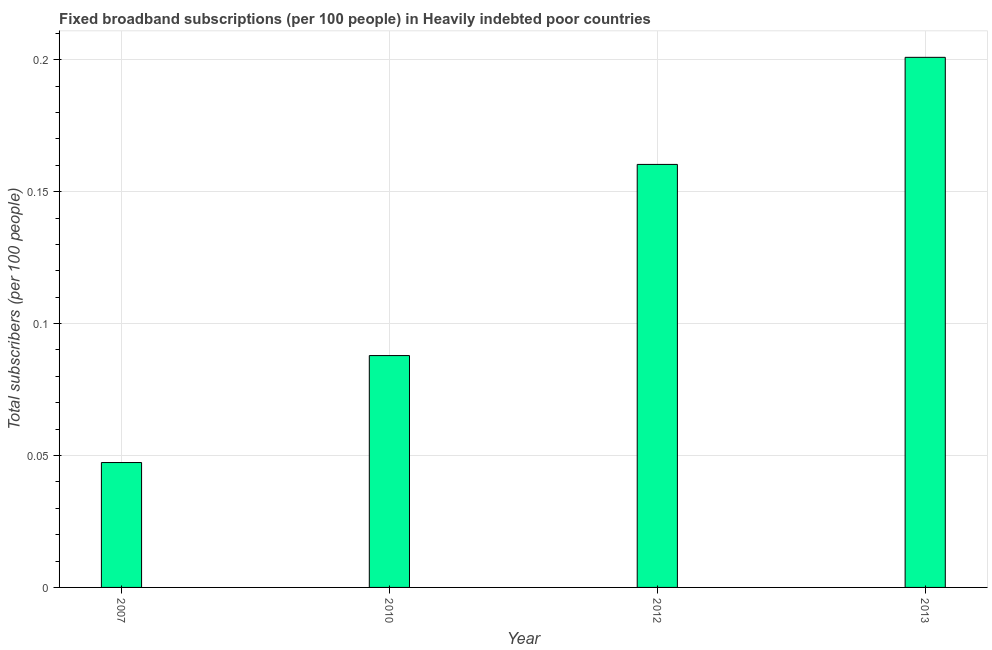Does the graph contain any zero values?
Keep it short and to the point. No. Does the graph contain grids?
Provide a succinct answer. Yes. What is the title of the graph?
Your response must be concise. Fixed broadband subscriptions (per 100 people) in Heavily indebted poor countries. What is the label or title of the X-axis?
Your answer should be very brief. Year. What is the label or title of the Y-axis?
Provide a succinct answer. Total subscribers (per 100 people). What is the total number of fixed broadband subscriptions in 2007?
Your answer should be compact. 0.05. Across all years, what is the maximum total number of fixed broadband subscriptions?
Ensure brevity in your answer.  0.2. Across all years, what is the minimum total number of fixed broadband subscriptions?
Your response must be concise. 0.05. In which year was the total number of fixed broadband subscriptions maximum?
Offer a very short reply. 2013. In which year was the total number of fixed broadband subscriptions minimum?
Your answer should be very brief. 2007. What is the sum of the total number of fixed broadband subscriptions?
Ensure brevity in your answer.  0.5. What is the difference between the total number of fixed broadband subscriptions in 2007 and 2013?
Give a very brief answer. -0.15. What is the average total number of fixed broadband subscriptions per year?
Offer a very short reply. 0.12. What is the median total number of fixed broadband subscriptions?
Your response must be concise. 0.12. In how many years, is the total number of fixed broadband subscriptions greater than 0.08 ?
Give a very brief answer. 3. Do a majority of the years between 2007 and 2012 (inclusive) have total number of fixed broadband subscriptions greater than 0.16 ?
Provide a short and direct response. No. What is the ratio of the total number of fixed broadband subscriptions in 2007 to that in 2010?
Keep it short and to the point. 0.54. Is the difference between the total number of fixed broadband subscriptions in 2007 and 2013 greater than the difference between any two years?
Ensure brevity in your answer.  Yes. What is the difference between the highest and the second highest total number of fixed broadband subscriptions?
Your answer should be very brief. 0.04. Is the sum of the total number of fixed broadband subscriptions in 2010 and 2013 greater than the maximum total number of fixed broadband subscriptions across all years?
Your answer should be compact. Yes. What is the difference between the highest and the lowest total number of fixed broadband subscriptions?
Give a very brief answer. 0.15. How many bars are there?
Provide a succinct answer. 4. How many years are there in the graph?
Offer a terse response. 4. What is the Total subscribers (per 100 people) of 2007?
Make the answer very short. 0.05. What is the Total subscribers (per 100 people) of 2010?
Your answer should be compact. 0.09. What is the Total subscribers (per 100 people) of 2012?
Give a very brief answer. 0.16. What is the Total subscribers (per 100 people) of 2013?
Give a very brief answer. 0.2. What is the difference between the Total subscribers (per 100 people) in 2007 and 2010?
Your response must be concise. -0.04. What is the difference between the Total subscribers (per 100 people) in 2007 and 2012?
Give a very brief answer. -0.11. What is the difference between the Total subscribers (per 100 people) in 2007 and 2013?
Make the answer very short. -0.15. What is the difference between the Total subscribers (per 100 people) in 2010 and 2012?
Provide a short and direct response. -0.07. What is the difference between the Total subscribers (per 100 people) in 2010 and 2013?
Ensure brevity in your answer.  -0.11. What is the difference between the Total subscribers (per 100 people) in 2012 and 2013?
Your answer should be compact. -0.04. What is the ratio of the Total subscribers (per 100 people) in 2007 to that in 2010?
Offer a very short reply. 0.54. What is the ratio of the Total subscribers (per 100 people) in 2007 to that in 2012?
Your response must be concise. 0.29. What is the ratio of the Total subscribers (per 100 people) in 2007 to that in 2013?
Provide a short and direct response. 0.24. What is the ratio of the Total subscribers (per 100 people) in 2010 to that in 2012?
Give a very brief answer. 0.55. What is the ratio of the Total subscribers (per 100 people) in 2010 to that in 2013?
Provide a short and direct response. 0.44. What is the ratio of the Total subscribers (per 100 people) in 2012 to that in 2013?
Offer a very short reply. 0.8. 